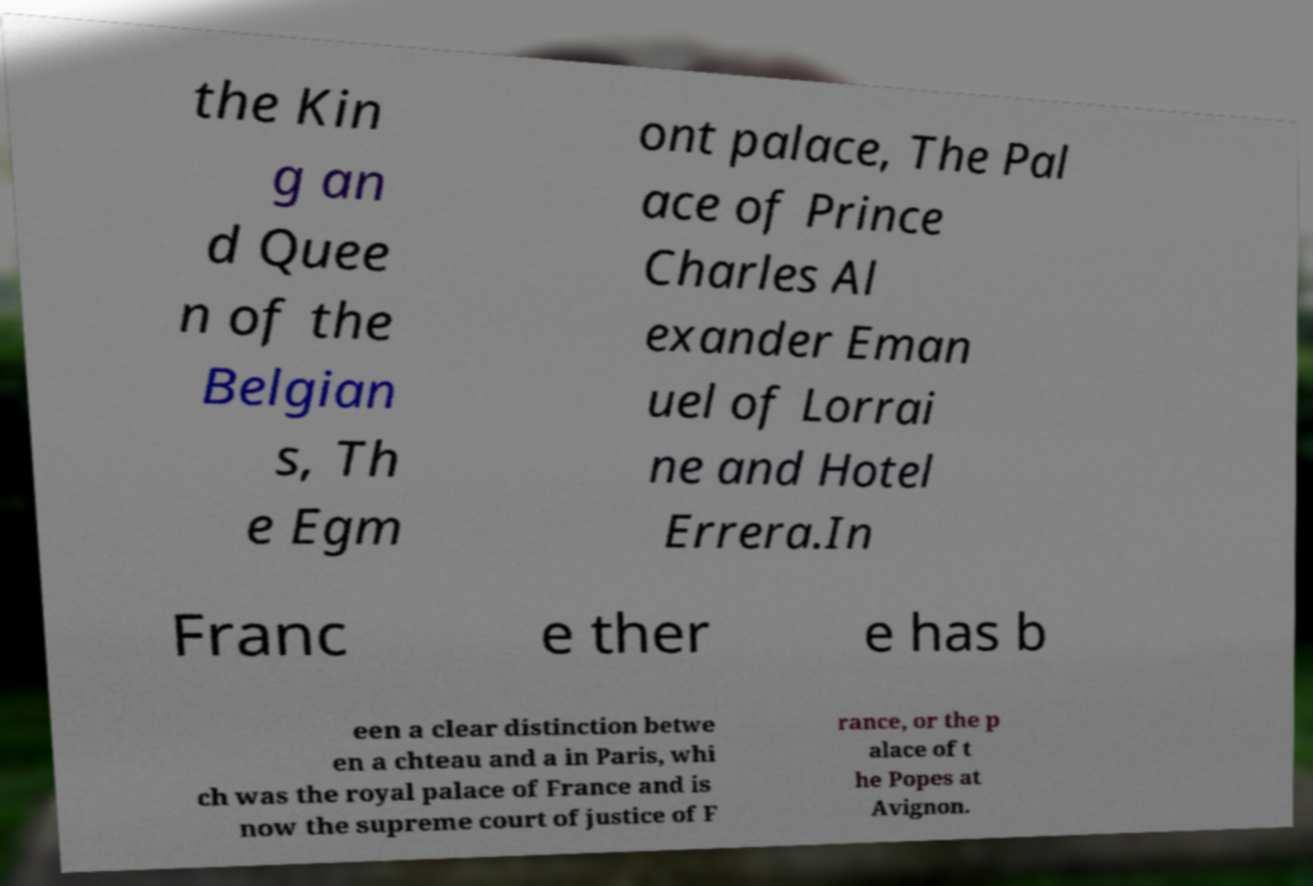I need the written content from this picture converted into text. Can you do that? the Kin g an d Quee n of the Belgian s, Th e Egm ont palace, The Pal ace of Prince Charles Al exander Eman uel of Lorrai ne and Hotel Errera.In Franc e ther e has b een a clear distinction betwe en a chteau and a in Paris, whi ch was the royal palace of France and is now the supreme court of justice of F rance, or the p alace of t he Popes at Avignon. 